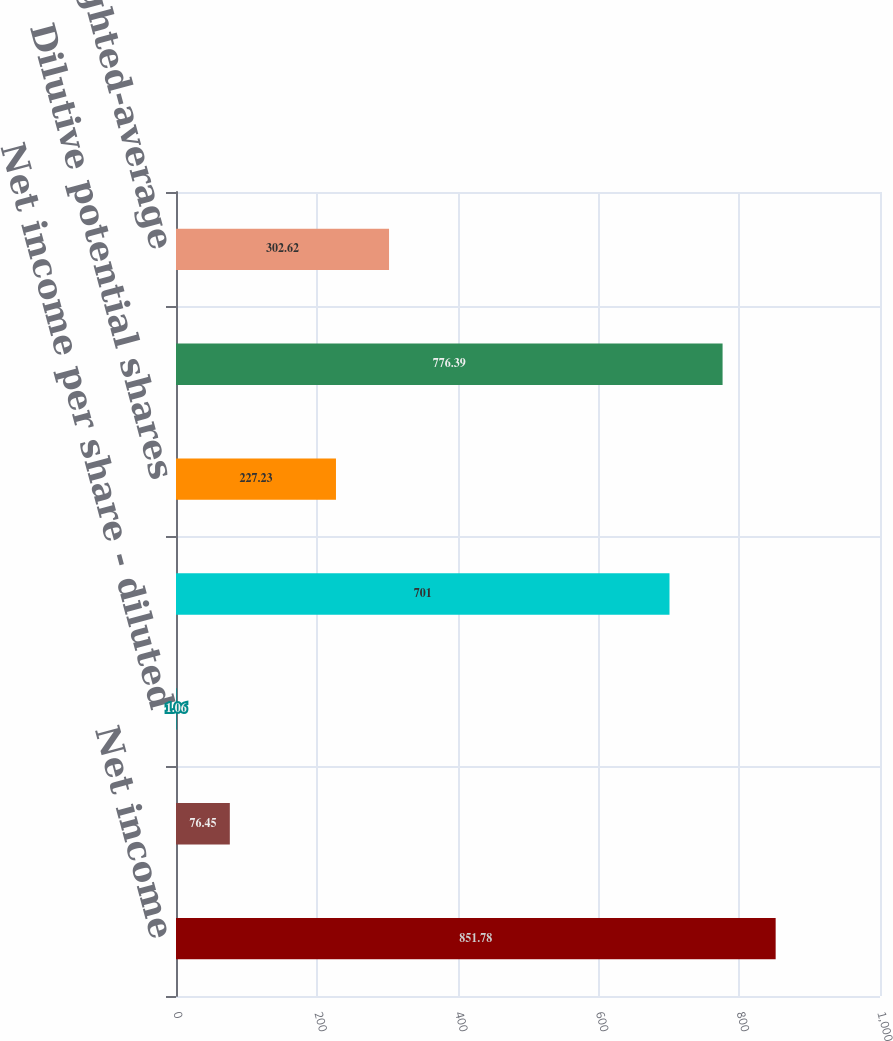<chart> <loc_0><loc_0><loc_500><loc_500><bar_chart><fcel>Net income<fcel>Net income per share - basic<fcel>Net income per share - diluted<fcel>Weighted-average outstanding<fcel>Dilutive potential shares<fcel>Weighted-average shares<fcel>Anti-dilutive weighted-average<nl><fcel>851.78<fcel>76.45<fcel>1.06<fcel>701<fcel>227.23<fcel>776.39<fcel>302.62<nl></chart> 